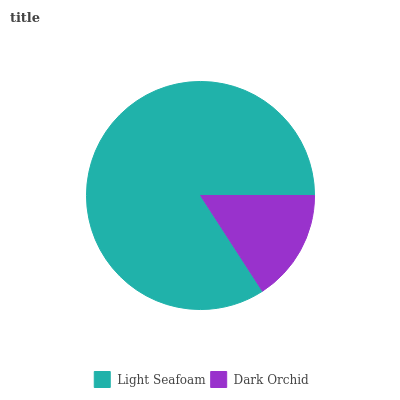Is Dark Orchid the minimum?
Answer yes or no. Yes. Is Light Seafoam the maximum?
Answer yes or no. Yes. Is Dark Orchid the maximum?
Answer yes or no. No. Is Light Seafoam greater than Dark Orchid?
Answer yes or no. Yes. Is Dark Orchid less than Light Seafoam?
Answer yes or no. Yes. Is Dark Orchid greater than Light Seafoam?
Answer yes or no. No. Is Light Seafoam less than Dark Orchid?
Answer yes or no. No. Is Light Seafoam the high median?
Answer yes or no. Yes. Is Dark Orchid the low median?
Answer yes or no. Yes. Is Dark Orchid the high median?
Answer yes or no. No. Is Light Seafoam the low median?
Answer yes or no. No. 